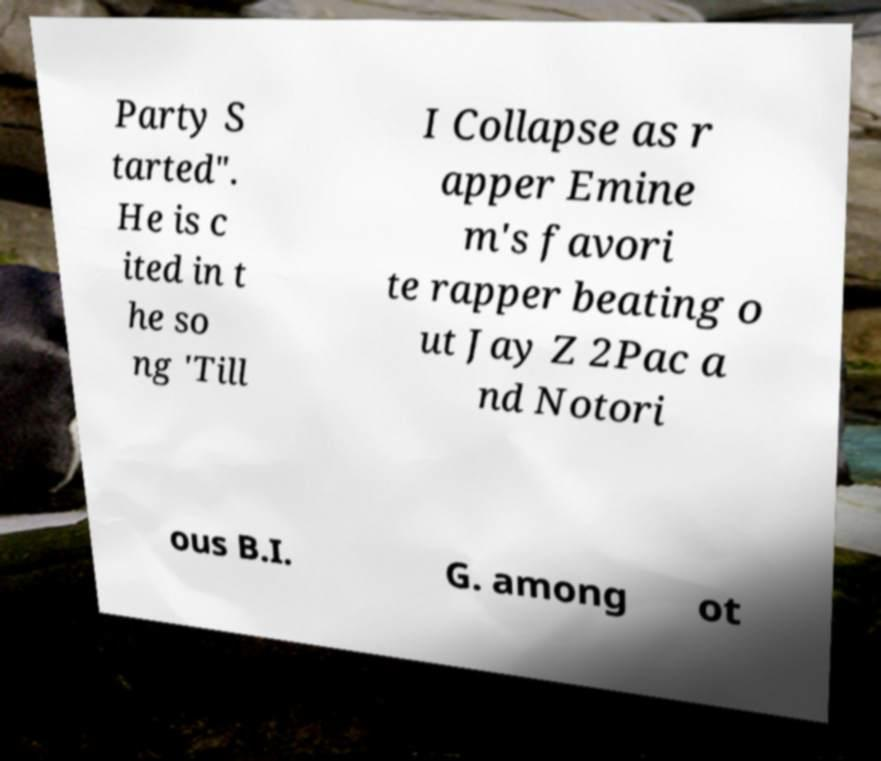Please identify and transcribe the text found in this image. Party S tarted". He is c ited in t he so ng 'Till I Collapse as r apper Emine m's favori te rapper beating o ut Jay Z 2Pac a nd Notori ous B.I. G. among ot 